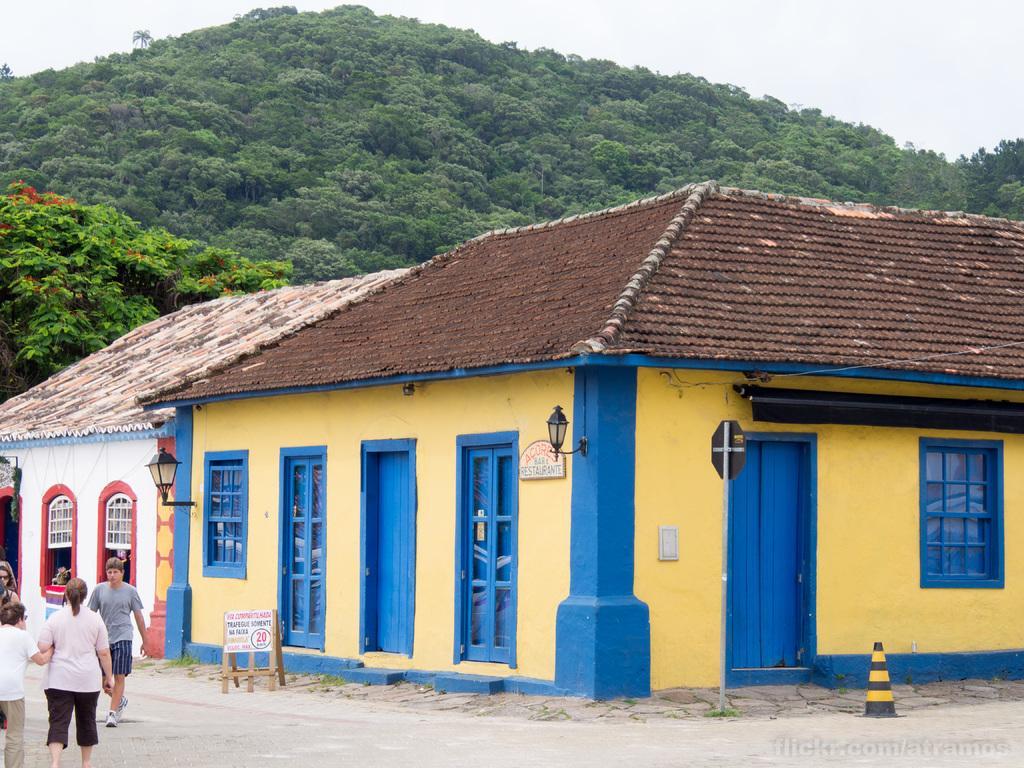Can you describe this image briefly? In this image there are seeds and trees. On the left there are people we can see a board. On the right there is a traffic cone. In the background there are hills and sky. 